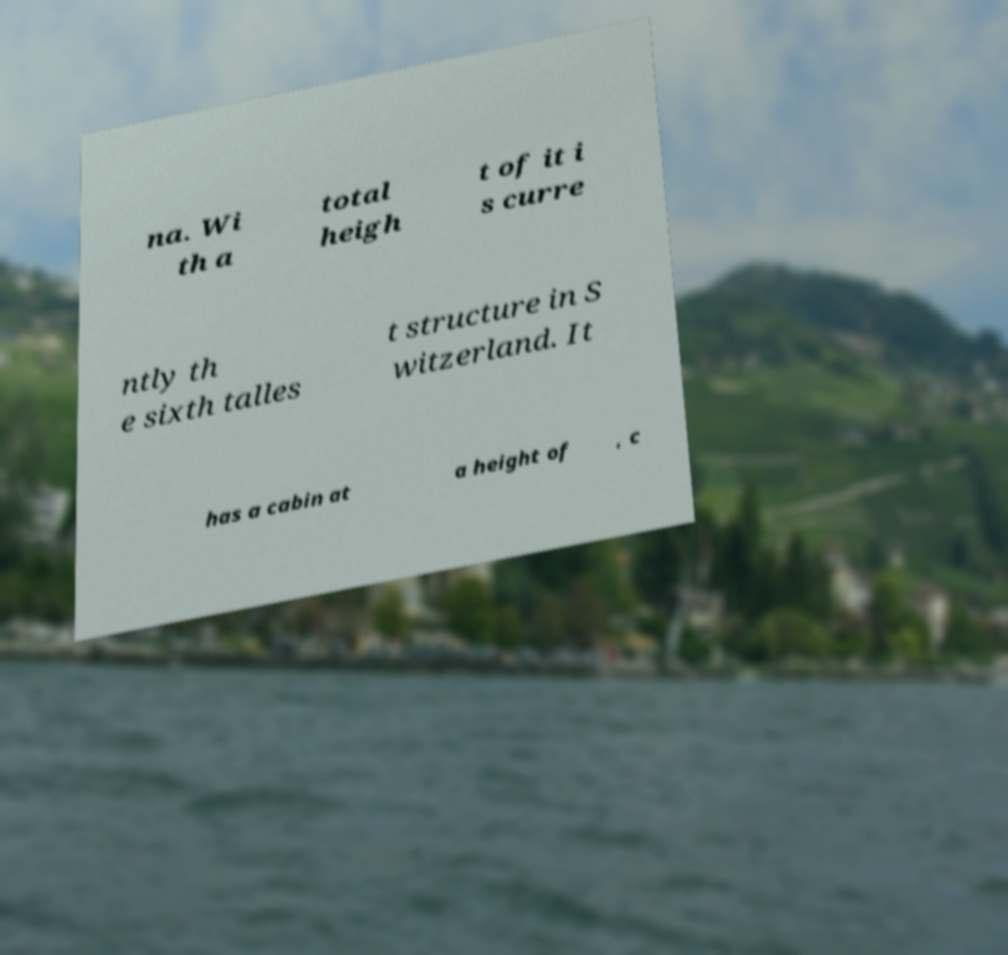Could you assist in decoding the text presented in this image and type it out clearly? na. Wi th a total heigh t of it i s curre ntly th e sixth talles t structure in S witzerland. It has a cabin at a height of , c 